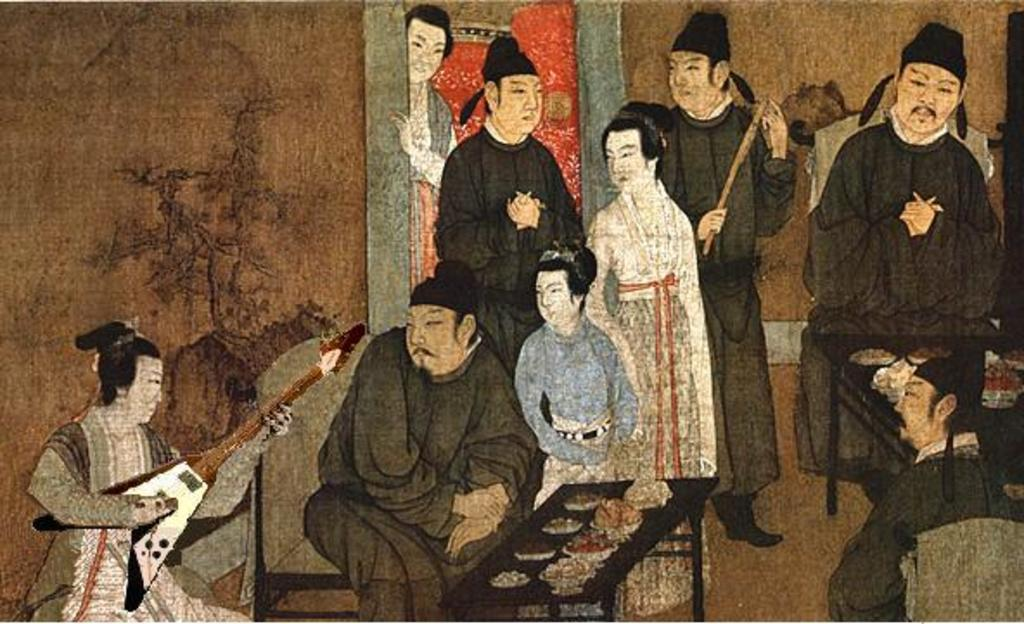What is the main subject of the image? The image contains a painting. What is depicted in the painting? The painting depicts people. What architectural feature is present in the painting? There is a wall in the painting. What type of furniture is visible in the painting? Chairs and tables are present in the painting. What is the woman in the painting holding? The woman is holding a guitar in the painting. What is on the tables in the painting? Dishes are on the tables in the painting. What type of cabbage is being used as a prop in the painting? There is no cabbage present in the painting; the woman is holding a guitar. 